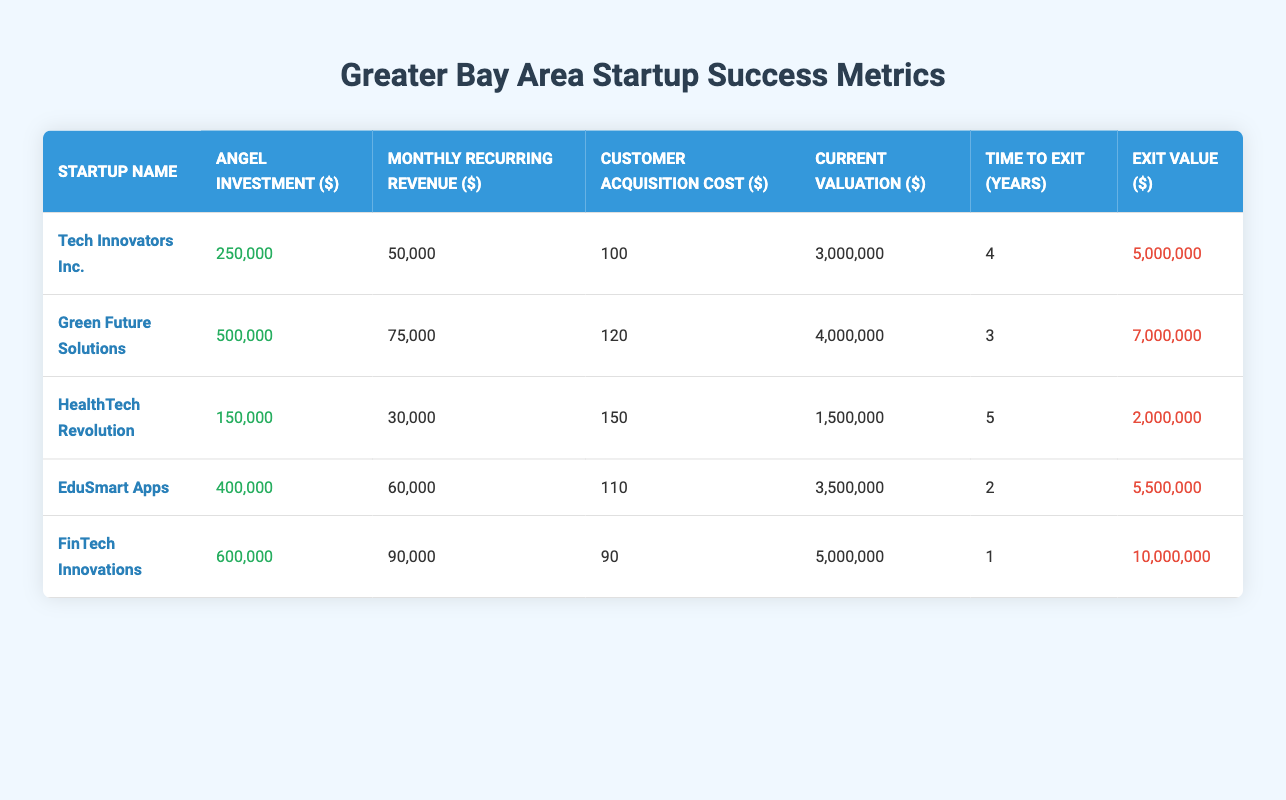What is the monthly recurring revenue of FinTech Innovations? The table lists FinTech Innovations with a monthly recurring revenue of 90,000 dollars.
Answer: 90,000 Which startup has the highest current valuation? Comparing the current valuations: Tech Innovators Inc. (3,000,000), Green Future Solutions (4,000,000), HealthTech Revolution (1,500,000), EduSmart Apps (3,500,000), and FinTech Innovations (5,000,000), FinTech Innovations has the highest valuation at 5,000,000 dollars.
Answer: FinTech Innovations What is the average time to exit for the startups listed? The times to exit are 4, 3, 5, 2, and 1 years. Summing them gives 4 + 3 + 5 + 2 + 1 = 15 years. Dividing by the number of startups (5) results in an average of 15/5 = 3 years.
Answer: 3 years Is the customer acquisition cost for Green Future Solutions lower than that of HealthTech Revolution? Green Future Solutions has a customer acquisition cost of 120 dollars, while HealthTech Revolution has a cost of 150 dollars. Since 120 is less than 150, the statement is true.
Answer: Yes Which startups have a monthly recurring revenue greater than 60,000? Evaluating the monthly recurring revenue: Tech Innovators Inc. (50,000), Green Future Solutions (75,000), HealthTech Revolution (30,000), EduSmart Apps (60,000), and FinTech Innovations (90,000). The ones above 60,000 are Green Future Solutions and FinTech Innovations.
Answer: Green Future Solutions, FinTech Innovations What is the exit value of EduSmart Apps? The table indicates that EduSmart Apps has an exit value of 5,500,000 dollars.
Answer: 5,500,000 How much total angel investment was received by all startups combined? The angel investments are 250,000, 500,000, 150,000, 400,000, and 600,000 dollars. The total is 250,000 + 500,000 + 150,000 + 400,000 + 600,000 = 1,900,000 dollars.
Answer: 1,900,000 Does any startup take less than 2 years to exit? The time to exit for EduSmart Apps is 2 years, while FinTech Innovations takes only 1 year. Since there is a startup (FinTech Innovations) that takes less than 2 years to exit, the answer is yes.
Answer: Yes What is the difference in exit value between FinTech Innovations and HealthTech Revolution? The exit value of FinTech Innovations is 10,000,000 dollars and that of HealthTech Revolution is 2,000,000 dollars. The difference is 10,000,000 - 2,000,000 = 8,000,000 dollars.
Answer: 8,000,000 